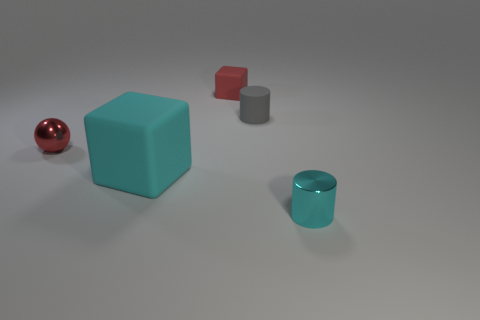Add 1 tiny cyan cylinders. How many objects exist? 6 Subtract all balls. How many objects are left? 4 Subtract all large cyan matte things. Subtract all spheres. How many objects are left? 3 Add 2 tiny red matte blocks. How many tiny red matte blocks are left? 3 Add 5 small red rubber cubes. How many small red rubber cubes exist? 6 Subtract 0 yellow spheres. How many objects are left? 5 